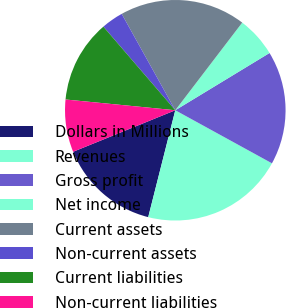<chart> <loc_0><loc_0><loc_500><loc_500><pie_chart><fcel>Dollars in Millions<fcel>Revenues<fcel>Gross profit<fcel>Net income<fcel>Current assets<fcel>Non-current assets<fcel>Current liabilities<fcel>Non-current liabilities<nl><fcel>14.91%<fcel>20.96%<fcel>16.68%<fcel>5.93%<fcel>18.46%<fcel>3.23%<fcel>12.14%<fcel>7.7%<nl></chart> 